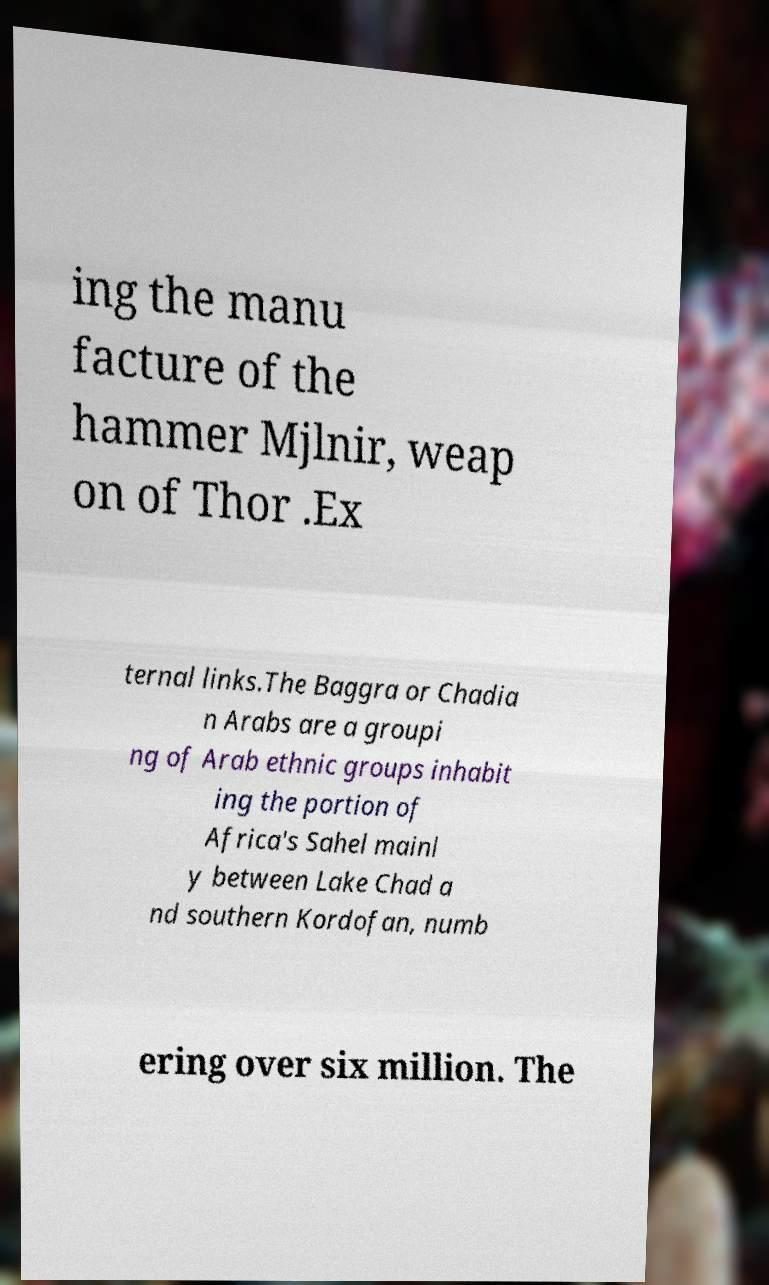Could you extract and type out the text from this image? ing the manu facture of the hammer Mjlnir, weap on of Thor .Ex ternal links.The Baggra or Chadia n Arabs are a groupi ng of Arab ethnic groups inhabit ing the portion of Africa's Sahel mainl y between Lake Chad a nd southern Kordofan, numb ering over six million. The 